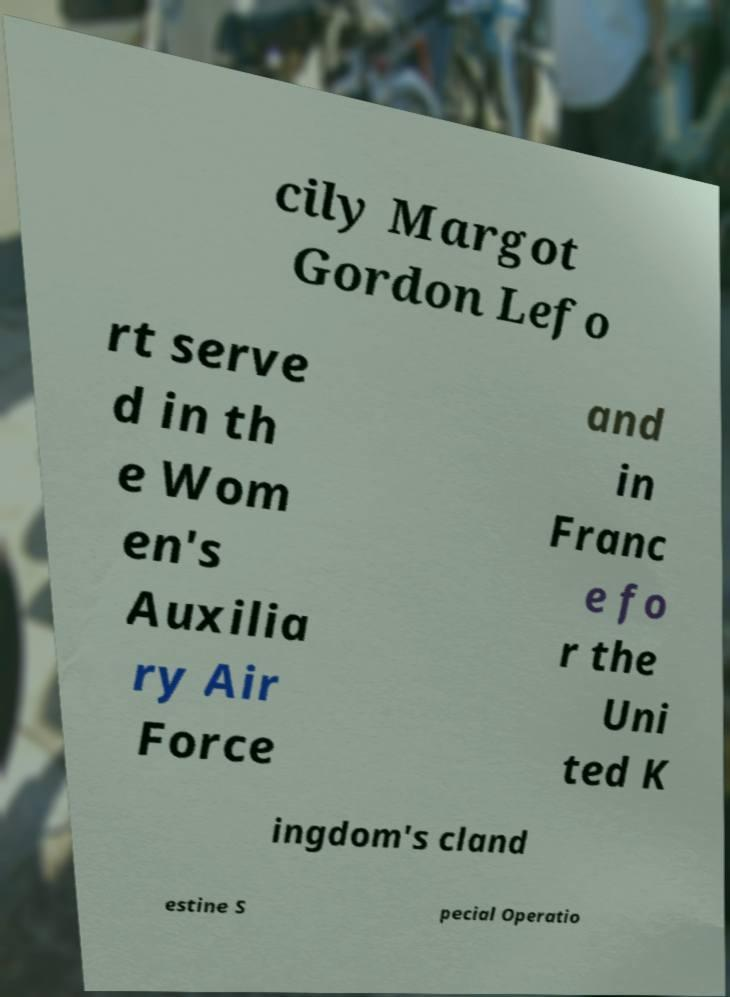For documentation purposes, I need the text within this image transcribed. Could you provide that? cily Margot Gordon Lefo rt serve d in th e Wom en's Auxilia ry Air Force and in Franc e fo r the Uni ted K ingdom's cland estine S pecial Operatio 